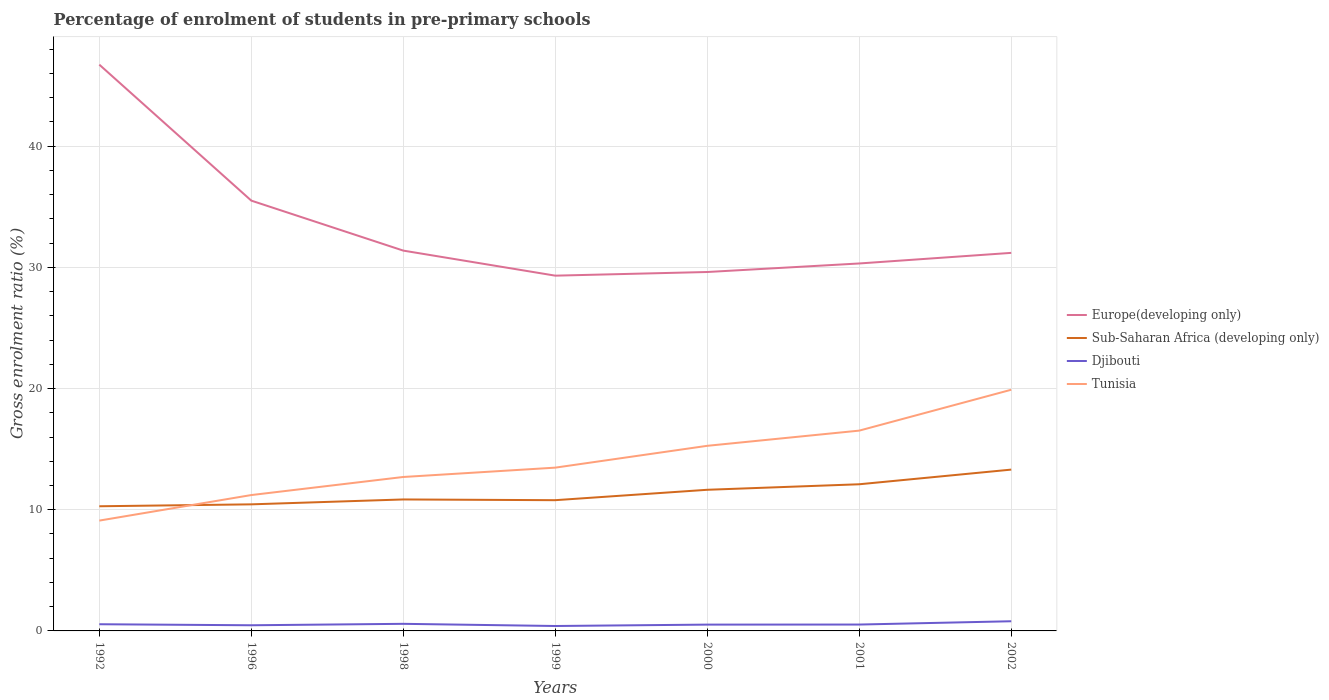Does the line corresponding to Tunisia intersect with the line corresponding to Europe(developing only)?
Your response must be concise. No. Across all years, what is the maximum percentage of students enrolled in pre-primary schools in Sub-Saharan Africa (developing only)?
Make the answer very short. 10.28. In which year was the percentage of students enrolled in pre-primary schools in Tunisia maximum?
Offer a terse response. 1992. What is the total percentage of students enrolled in pre-primary schools in Tunisia in the graph?
Your answer should be compact. -3.6. What is the difference between the highest and the second highest percentage of students enrolled in pre-primary schools in Sub-Saharan Africa (developing only)?
Ensure brevity in your answer.  3.03. How many lines are there?
Your response must be concise. 4. How many years are there in the graph?
Your answer should be very brief. 7. What is the difference between two consecutive major ticks on the Y-axis?
Your answer should be very brief. 10. Where does the legend appear in the graph?
Provide a short and direct response. Center right. What is the title of the graph?
Give a very brief answer. Percentage of enrolment of students in pre-primary schools. What is the label or title of the X-axis?
Offer a terse response. Years. What is the label or title of the Y-axis?
Make the answer very short. Gross enrolment ratio (%). What is the Gross enrolment ratio (%) of Europe(developing only) in 1992?
Ensure brevity in your answer.  46.72. What is the Gross enrolment ratio (%) in Sub-Saharan Africa (developing only) in 1992?
Provide a succinct answer. 10.28. What is the Gross enrolment ratio (%) in Djibouti in 1992?
Make the answer very short. 0.55. What is the Gross enrolment ratio (%) in Tunisia in 1992?
Your response must be concise. 9.1. What is the Gross enrolment ratio (%) in Europe(developing only) in 1996?
Your answer should be compact. 35.5. What is the Gross enrolment ratio (%) of Sub-Saharan Africa (developing only) in 1996?
Provide a succinct answer. 10.44. What is the Gross enrolment ratio (%) of Djibouti in 1996?
Your response must be concise. 0.47. What is the Gross enrolment ratio (%) of Tunisia in 1996?
Make the answer very short. 11.21. What is the Gross enrolment ratio (%) in Europe(developing only) in 1998?
Offer a terse response. 31.38. What is the Gross enrolment ratio (%) of Sub-Saharan Africa (developing only) in 1998?
Provide a succinct answer. 10.85. What is the Gross enrolment ratio (%) of Djibouti in 1998?
Your response must be concise. 0.58. What is the Gross enrolment ratio (%) of Tunisia in 1998?
Provide a short and direct response. 12.7. What is the Gross enrolment ratio (%) of Europe(developing only) in 1999?
Offer a terse response. 29.31. What is the Gross enrolment ratio (%) in Sub-Saharan Africa (developing only) in 1999?
Your answer should be compact. 10.79. What is the Gross enrolment ratio (%) in Djibouti in 1999?
Give a very brief answer. 0.41. What is the Gross enrolment ratio (%) in Tunisia in 1999?
Your response must be concise. 13.47. What is the Gross enrolment ratio (%) of Europe(developing only) in 2000?
Keep it short and to the point. 29.61. What is the Gross enrolment ratio (%) of Sub-Saharan Africa (developing only) in 2000?
Offer a very short reply. 11.65. What is the Gross enrolment ratio (%) of Djibouti in 2000?
Provide a short and direct response. 0.52. What is the Gross enrolment ratio (%) in Tunisia in 2000?
Offer a very short reply. 15.27. What is the Gross enrolment ratio (%) in Europe(developing only) in 2001?
Offer a very short reply. 30.32. What is the Gross enrolment ratio (%) of Sub-Saharan Africa (developing only) in 2001?
Provide a short and direct response. 12.1. What is the Gross enrolment ratio (%) in Djibouti in 2001?
Provide a succinct answer. 0.53. What is the Gross enrolment ratio (%) of Tunisia in 2001?
Ensure brevity in your answer.  16.53. What is the Gross enrolment ratio (%) in Europe(developing only) in 2002?
Make the answer very short. 31.19. What is the Gross enrolment ratio (%) in Sub-Saharan Africa (developing only) in 2002?
Offer a terse response. 13.31. What is the Gross enrolment ratio (%) in Djibouti in 2002?
Keep it short and to the point. 0.8. What is the Gross enrolment ratio (%) in Tunisia in 2002?
Make the answer very short. 19.9. Across all years, what is the maximum Gross enrolment ratio (%) in Europe(developing only)?
Your response must be concise. 46.72. Across all years, what is the maximum Gross enrolment ratio (%) of Sub-Saharan Africa (developing only)?
Keep it short and to the point. 13.31. Across all years, what is the maximum Gross enrolment ratio (%) of Djibouti?
Your answer should be compact. 0.8. Across all years, what is the maximum Gross enrolment ratio (%) in Tunisia?
Provide a succinct answer. 19.9. Across all years, what is the minimum Gross enrolment ratio (%) of Europe(developing only)?
Ensure brevity in your answer.  29.31. Across all years, what is the minimum Gross enrolment ratio (%) of Sub-Saharan Africa (developing only)?
Offer a very short reply. 10.28. Across all years, what is the minimum Gross enrolment ratio (%) in Djibouti?
Provide a short and direct response. 0.41. Across all years, what is the minimum Gross enrolment ratio (%) of Tunisia?
Your answer should be compact. 9.1. What is the total Gross enrolment ratio (%) in Europe(developing only) in the graph?
Provide a succinct answer. 234.04. What is the total Gross enrolment ratio (%) of Sub-Saharan Africa (developing only) in the graph?
Your answer should be very brief. 79.42. What is the total Gross enrolment ratio (%) in Djibouti in the graph?
Offer a very short reply. 3.85. What is the total Gross enrolment ratio (%) in Tunisia in the graph?
Make the answer very short. 98.19. What is the difference between the Gross enrolment ratio (%) of Europe(developing only) in 1992 and that in 1996?
Give a very brief answer. 11.22. What is the difference between the Gross enrolment ratio (%) of Sub-Saharan Africa (developing only) in 1992 and that in 1996?
Make the answer very short. -0.16. What is the difference between the Gross enrolment ratio (%) in Djibouti in 1992 and that in 1996?
Offer a very short reply. 0.09. What is the difference between the Gross enrolment ratio (%) in Tunisia in 1992 and that in 1996?
Make the answer very short. -2.11. What is the difference between the Gross enrolment ratio (%) of Europe(developing only) in 1992 and that in 1998?
Provide a succinct answer. 15.34. What is the difference between the Gross enrolment ratio (%) in Sub-Saharan Africa (developing only) in 1992 and that in 1998?
Make the answer very short. -0.56. What is the difference between the Gross enrolment ratio (%) of Djibouti in 1992 and that in 1998?
Your answer should be compact. -0.03. What is the difference between the Gross enrolment ratio (%) of Tunisia in 1992 and that in 1998?
Make the answer very short. -3.6. What is the difference between the Gross enrolment ratio (%) in Europe(developing only) in 1992 and that in 1999?
Offer a very short reply. 17.41. What is the difference between the Gross enrolment ratio (%) in Sub-Saharan Africa (developing only) in 1992 and that in 1999?
Offer a terse response. -0.5. What is the difference between the Gross enrolment ratio (%) of Djibouti in 1992 and that in 1999?
Make the answer very short. 0.15. What is the difference between the Gross enrolment ratio (%) in Tunisia in 1992 and that in 1999?
Give a very brief answer. -4.37. What is the difference between the Gross enrolment ratio (%) of Europe(developing only) in 1992 and that in 2000?
Make the answer very short. 17.11. What is the difference between the Gross enrolment ratio (%) in Sub-Saharan Africa (developing only) in 1992 and that in 2000?
Provide a short and direct response. -1.36. What is the difference between the Gross enrolment ratio (%) in Djibouti in 1992 and that in 2000?
Keep it short and to the point. 0.03. What is the difference between the Gross enrolment ratio (%) in Tunisia in 1992 and that in 2000?
Offer a very short reply. -6.17. What is the difference between the Gross enrolment ratio (%) of Europe(developing only) in 1992 and that in 2001?
Offer a terse response. 16.41. What is the difference between the Gross enrolment ratio (%) in Sub-Saharan Africa (developing only) in 1992 and that in 2001?
Offer a very short reply. -1.82. What is the difference between the Gross enrolment ratio (%) of Djibouti in 1992 and that in 2001?
Give a very brief answer. 0.03. What is the difference between the Gross enrolment ratio (%) in Tunisia in 1992 and that in 2001?
Your answer should be very brief. -7.42. What is the difference between the Gross enrolment ratio (%) in Europe(developing only) in 1992 and that in 2002?
Offer a very short reply. 15.53. What is the difference between the Gross enrolment ratio (%) in Sub-Saharan Africa (developing only) in 1992 and that in 2002?
Your response must be concise. -3.03. What is the difference between the Gross enrolment ratio (%) in Djibouti in 1992 and that in 2002?
Your response must be concise. -0.25. What is the difference between the Gross enrolment ratio (%) of Tunisia in 1992 and that in 2002?
Give a very brief answer. -10.8. What is the difference between the Gross enrolment ratio (%) in Europe(developing only) in 1996 and that in 1998?
Ensure brevity in your answer.  4.12. What is the difference between the Gross enrolment ratio (%) of Sub-Saharan Africa (developing only) in 1996 and that in 1998?
Make the answer very short. -0.4. What is the difference between the Gross enrolment ratio (%) in Djibouti in 1996 and that in 1998?
Offer a very short reply. -0.12. What is the difference between the Gross enrolment ratio (%) of Tunisia in 1996 and that in 1998?
Provide a short and direct response. -1.49. What is the difference between the Gross enrolment ratio (%) in Europe(developing only) in 1996 and that in 1999?
Offer a terse response. 6.19. What is the difference between the Gross enrolment ratio (%) in Sub-Saharan Africa (developing only) in 1996 and that in 1999?
Keep it short and to the point. -0.34. What is the difference between the Gross enrolment ratio (%) of Djibouti in 1996 and that in 1999?
Ensure brevity in your answer.  0.06. What is the difference between the Gross enrolment ratio (%) in Tunisia in 1996 and that in 1999?
Give a very brief answer. -2.26. What is the difference between the Gross enrolment ratio (%) of Europe(developing only) in 1996 and that in 2000?
Provide a succinct answer. 5.89. What is the difference between the Gross enrolment ratio (%) in Sub-Saharan Africa (developing only) in 1996 and that in 2000?
Your response must be concise. -1.2. What is the difference between the Gross enrolment ratio (%) of Djibouti in 1996 and that in 2000?
Make the answer very short. -0.05. What is the difference between the Gross enrolment ratio (%) of Tunisia in 1996 and that in 2000?
Keep it short and to the point. -4.06. What is the difference between the Gross enrolment ratio (%) of Europe(developing only) in 1996 and that in 2001?
Provide a succinct answer. 5.19. What is the difference between the Gross enrolment ratio (%) in Sub-Saharan Africa (developing only) in 1996 and that in 2001?
Provide a short and direct response. -1.66. What is the difference between the Gross enrolment ratio (%) of Djibouti in 1996 and that in 2001?
Your answer should be compact. -0.06. What is the difference between the Gross enrolment ratio (%) of Tunisia in 1996 and that in 2001?
Provide a short and direct response. -5.32. What is the difference between the Gross enrolment ratio (%) of Europe(developing only) in 1996 and that in 2002?
Provide a short and direct response. 4.31. What is the difference between the Gross enrolment ratio (%) in Sub-Saharan Africa (developing only) in 1996 and that in 2002?
Keep it short and to the point. -2.87. What is the difference between the Gross enrolment ratio (%) of Djibouti in 1996 and that in 2002?
Your response must be concise. -0.33. What is the difference between the Gross enrolment ratio (%) of Tunisia in 1996 and that in 2002?
Your answer should be compact. -8.69. What is the difference between the Gross enrolment ratio (%) in Europe(developing only) in 1998 and that in 1999?
Your answer should be compact. 2.07. What is the difference between the Gross enrolment ratio (%) of Sub-Saharan Africa (developing only) in 1998 and that in 1999?
Keep it short and to the point. 0.06. What is the difference between the Gross enrolment ratio (%) of Djibouti in 1998 and that in 1999?
Your response must be concise. 0.18. What is the difference between the Gross enrolment ratio (%) in Tunisia in 1998 and that in 1999?
Your answer should be very brief. -0.77. What is the difference between the Gross enrolment ratio (%) of Europe(developing only) in 1998 and that in 2000?
Give a very brief answer. 1.77. What is the difference between the Gross enrolment ratio (%) of Sub-Saharan Africa (developing only) in 1998 and that in 2000?
Your answer should be very brief. -0.8. What is the difference between the Gross enrolment ratio (%) of Djibouti in 1998 and that in 2000?
Make the answer very short. 0.06. What is the difference between the Gross enrolment ratio (%) in Tunisia in 1998 and that in 2000?
Provide a succinct answer. -2.57. What is the difference between the Gross enrolment ratio (%) of Europe(developing only) in 1998 and that in 2001?
Keep it short and to the point. 1.06. What is the difference between the Gross enrolment ratio (%) in Sub-Saharan Africa (developing only) in 1998 and that in 2001?
Your response must be concise. -1.25. What is the difference between the Gross enrolment ratio (%) in Djibouti in 1998 and that in 2001?
Your response must be concise. 0.06. What is the difference between the Gross enrolment ratio (%) of Tunisia in 1998 and that in 2001?
Give a very brief answer. -3.83. What is the difference between the Gross enrolment ratio (%) in Europe(developing only) in 1998 and that in 2002?
Your answer should be compact. 0.19. What is the difference between the Gross enrolment ratio (%) in Sub-Saharan Africa (developing only) in 1998 and that in 2002?
Give a very brief answer. -2.46. What is the difference between the Gross enrolment ratio (%) in Djibouti in 1998 and that in 2002?
Provide a succinct answer. -0.21. What is the difference between the Gross enrolment ratio (%) of Tunisia in 1998 and that in 2002?
Your answer should be compact. -7.2. What is the difference between the Gross enrolment ratio (%) of Europe(developing only) in 1999 and that in 2000?
Offer a terse response. -0.3. What is the difference between the Gross enrolment ratio (%) in Sub-Saharan Africa (developing only) in 1999 and that in 2000?
Your answer should be compact. -0.86. What is the difference between the Gross enrolment ratio (%) of Djibouti in 1999 and that in 2000?
Your answer should be very brief. -0.12. What is the difference between the Gross enrolment ratio (%) of Tunisia in 1999 and that in 2000?
Keep it short and to the point. -1.8. What is the difference between the Gross enrolment ratio (%) in Europe(developing only) in 1999 and that in 2001?
Provide a succinct answer. -1.01. What is the difference between the Gross enrolment ratio (%) in Sub-Saharan Africa (developing only) in 1999 and that in 2001?
Keep it short and to the point. -1.31. What is the difference between the Gross enrolment ratio (%) of Djibouti in 1999 and that in 2001?
Keep it short and to the point. -0.12. What is the difference between the Gross enrolment ratio (%) in Tunisia in 1999 and that in 2001?
Provide a short and direct response. -3.05. What is the difference between the Gross enrolment ratio (%) of Europe(developing only) in 1999 and that in 2002?
Your response must be concise. -1.88. What is the difference between the Gross enrolment ratio (%) of Sub-Saharan Africa (developing only) in 1999 and that in 2002?
Keep it short and to the point. -2.52. What is the difference between the Gross enrolment ratio (%) of Djibouti in 1999 and that in 2002?
Give a very brief answer. -0.39. What is the difference between the Gross enrolment ratio (%) in Tunisia in 1999 and that in 2002?
Give a very brief answer. -6.43. What is the difference between the Gross enrolment ratio (%) of Europe(developing only) in 2000 and that in 2001?
Offer a very short reply. -0.7. What is the difference between the Gross enrolment ratio (%) in Sub-Saharan Africa (developing only) in 2000 and that in 2001?
Your answer should be compact. -0.46. What is the difference between the Gross enrolment ratio (%) of Djibouti in 2000 and that in 2001?
Your answer should be very brief. -0.01. What is the difference between the Gross enrolment ratio (%) in Tunisia in 2000 and that in 2001?
Offer a terse response. -1.25. What is the difference between the Gross enrolment ratio (%) of Europe(developing only) in 2000 and that in 2002?
Your answer should be very brief. -1.58. What is the difference between the Gross enrolment ratio (%) in Sub-Saharan Africa (developing only) in 2000 and that in 2002?
Make the answer very short. -1.67. What is the difference between the Gross enrolment ratio (%) of Djibouti in 2000 and that in 2002?
Ensure brevity in your answer.  -0.28. What is the difference between the Gross enrolment ratio (%) in Tunisia in 2000 and that in 2002?
Your answer should be compact. -4.63. What is the difference between the Gross enrolment ratio (%) in Europe(developing only) in 2001 and that in 2002?
Make the answer very short. -0.88. What is the difference between the Gross enrolment ratio (%) in Sub-Saharan Africa (developing only) in 2001 and that in 2002?
Provide a succinct answer. -1.21. What is the difference between the Gross enrolment ratio (%) in Djibouti in 2001 and that in 2002?
Your answer should be compact. -0.27. What is the difference between the Gross enrolment ratio (%) of Tunisia in 2001 and that in 2002?
Give a very brief answer. -3.37. What is the difference between the Gross enrolment ratio (%) of Europe(developing only) in 1992 and the Gross enrolment ratio (%) of Sub-Saharan Africa (developing only) in 1996?
Your response must be concise. 36.28. What is the difference between the Gross enrolment ratio (%) in Europe(developing only) in 1992 and the Gross enrolment ratio (%) in Djibouti in 1996?
Give a very brief answer. 46.26. What is the difference between the Gross enrolment ratio (%) of Europe(developing only) in 1992 and the Gross enrolment ratio (%) of Tunisia in 1996?
Provide a succinct answer. 35.51. What is the difference between the Gross enrolment ratio (%) in Sub-Saharan Africa (developing only) in 1992 and the Gross enrolment ratio (%) in Djibouti in 1996?
Keep it short and to the point. 9.82. What is the difference between the Gross enrolment ratio (%) in Sub-Saharan Africa (developing only) in 1992 and the Gross enrolment ratio (%) in Tunisia in 1996?
Your response must be concise. -0.93. What is the difference between the Gross enrolment ratio (%) of Djibouti in 1992 and the Gross enrolment ratio (%) of Tunisia in 1996?
Offer a terse response. -10.66. What is the difference between the Gross enrolment ratio (%) in Europe(developing only) in 1992 and the Gross enrolment ratio (%) in Sub-Saharan Africa (developing only) in 1998?
Make the answer very short. 35.88. What is the difference between the Gross enrolment ratio (%) of Europe(developing only) in 1992 and the Gross enrolment ratio (%) of Djibouti in 1998?
Your response must be concise. 46.14. What is the difference between the Gross enrolment ratio (%) in Europe(developing only) in 1992 and the Gross enrolment ratio (%) in Tunisia in 1998?
Your response must be concise. 34.02. What is the difference between the Gross enrolment ratio (%) in Sub-Saharan Africa (developing only) in 1992 and the Gross enrolment ratio (%) in Djibouti in 1998?
Your answer should be compact. 9.7. What is the difference between the Gross enrolment ratio (%) in Sub-Saharan Africa (developing only) in 1992 and the Gross enrolment ratio (%) in Tunisia in 1998?
Provide a short and direct response. -2.42. What is the difference between the Gross enrolment ratio (%) of Djibouti in 1992 and the Gross enrolment ratio (%) of Tunisia in 1998?
Offer a very short reply. -12.15. What is the difference between the Gross enrolment ratio (%) in Europe(developing only) in 1992 and the Gross enrolment ratio (%) in Sub-Saharan Africa (developing only) in 1999?
Your answer should be very brief. 35.94. What is the difference between the Gross enrolment ratio (%) of Europe(developing only) in 1992 and the Gross enrolment ratio (%) of Djibouti in 1999?
Provide a short and direct response. 46.32. What is the difference between the Gross enrolment ratio (%) in Europe(developing only) in 1992 and the Gross enrolment ratio (%) in Tunisia in 1999?
Your answer should be very brief. 33.25. What is the difference between the Gross enrolment ratio (%) of Sub-Saharan Africa (developing only) in 1992 and the Gross enrolment ratio (%) of Djibouti in 1999?
Give a very brief answer. 9.88. What is the difference between the Gross enrolment ratio (%) in Sub-Saharan Africa (developing only) in 1992 and the Gross enrolment ratio (%) in Tunisia in 1999?
Make the answer very short. -3.19. What is the difference between the Gross enrolment ratio (%) in Djibouti in 1992 and the Gross enrolment ratio (%) in Tunisia in 1999?
Your response must be concise. -12.92. What is the difference between the Gross enrolment ratio (%) of Europe(developing only) in 1992 and the Gross enrolment ratio (%) of Sub-Saharan Africa (developing only) in 2000?
Make the answer very short. 35.08. What is the difference between the Gross enrolment ratio (%) of Europe(developing only) in 1992 and the Gross enrolment ratio (%) of Djibouti in 2000?
Provide a succinct answer. 46.2. What is the difference between the Gross enrolment ratio (%) in Europe(developing only) in 1992 and the Gross enrolment ratio (%) in Tunisia in 2000?
Make the answer very short. 31.45. What is the difference between the Gross enrolment ratio (%) of Sub-Saharan Africa (developing only) in 1992 and the Gross enrolment ratio (%) of Djibouti in 2000?
Your response must be concise. 9.76. What is the difference between the Gross enrolment ratio (%) in Sub-Saharan Africa (developing only) in 1992 and the Gross enrolment ratio (%) in Tunisia in 2000?
Your response must be concise. -4.99. What is the difference between the Gross enrolment ratio (%) in Djibouti in 1992 and the Gross enrolment ratio (%) in Tunisia in 2000?
Keep it short and to the point. -14.72. What is the difference between the Gross enrolment ratio (%) in Europe(developing only) in 1992 and the Gross enrolment ratio (%) in Sub-Saharan Africa (developing only) in 2001?
Your answer should be very brief. 34.62. What is the difference between the Gross enrolment ratio (%) of Europe(developing only) in 1992 and the Gross enrolment ratio (%) of Djibouti in 2001?
Your answer should be very brief. 46.2. What is the difference between the Gross enrolment ratio (%) in Europe(developing only) in 1992 and the Gross enrolment ratio (%) in Tunisia in 2001?
Your answer should be compact. 30.2. What is the difference between the Gross enrolment ratio (%) of Sub-Saharan Africa (developing only) in 1992 and the Gross enrolment ratio (%) of Djibouti in 2001?
Provide a short and direct response. 9.76. What is the difference between the Gross enrolment ratio (%) of Sub-Saharan Africa (developing only) in 1992 and the Gross enrolment ratio (%) of Tunisia in 2001?
Offer a terse response. -6.24. What is the difference between the Gross enrolment ratio (%) of Djibouti in 1992 and the Gross enrolment ratio (%) of Tunisia in 2001?
Give a very brief answer. -15.97. What is the difference between the Gross enrolment ratio (%) in Europe(developing only) in 1992 and the Gross enrolment ratio (%) in Sub-Saharan Africa (developing only) in 2002?
Your answer should be very brief. 33.41. What is the difference between the Gross enrolment ratio (%) in Europe(developing only) in 1992 and the Gross enrolment ratio (%) in Djibouti in 2002?
Keep it short and to the point. 45.93. What is the difference between the Gross enrolment ratio (%) of Europe(developing only) in 1992 and the Gross enrolment ratio (%) of Tunisia in 2002?
Keep it short and to the point. 26.82. What is the difference between the Gross enrolment ratio (%) of Sub-Saharan Africa (developing only) in 1992 and the Gross enrolment ratio (%) of Djibouti in 2002?
Offer a very short reply. 9.49. What is the difference between the Gross enrolment ratio (%) of Sub-Saharan Africa (developing only) in 1992 and the Gross enrolment ratio (%) of Tunisia in 2002?
Keep it short and to the point. -9.61. What is the difference between the Gross enrolment ratio (%) in Djibouti in 1992 and the Gross enrolment ratio (%) in Tunisia in 2002?
Ensure brevity in your answer.  -19.35. What is the difference between the Gross enrolment ratio (%) of Europe(developing only) in 1996 and the Gross enrolment ratio (%) of Sub-Saharan Africa (developing only) in 1998?
Keep it short and to the point. 24.66. What is the difference between the Gross enrolment ratio (%) of Europe(developing only) in 1996 and the Gross enrolment ratio (%) of Djibouti in 1998?
Your answer should be compact. 34.92. What is the difference between the Gross enrolment ratio (%) of Europe(developing only) in 1996 and the Gross enrolment ratio (%) of Tunisia in 1998?
Your answer should be compact. 22.8. What is the difference between the Gross enrolment ratio (%) in Sub-Saharan Africa (developing only) in 1996 and the Gross enrolment ratio (%) in Djibouti in 1998?
Provide a succinct answer. 9.86. What is the difference between the Gross enrolment ratio (%) of Sub-Saharan Africa (developing only) in 1996 and the Gross enrolment ratio (%) of Tunisia in 1998?
Provide a succinct answer. -2.26. What is the difference between the Gross enrolment ratio (%) in Djibouti in 1996 and the Gross enrolment ratio (%) in Tunisia in 1998?
Your answer should be compact. -12.23. What is the difference between the Gross enrolment ratio (%) in Europe(developing only) in 1996 and the Gross enrolment ratio (%) in Sub-Saharan Africa (developing only) in 1999?
Give a very brief answer. 24.72. What is the difference between the Gross enrolment ratio (%) of Europe(developing only) in 1996 and the Gross enrolment ratio (%) of Djibouti in 1999?
Offer a terse response. 35.1. What is the difference between the Gross enrolment ratio (%) of Europe(developing only) in 1996 and the Gross enrolment ratio (%) of Tunisia in 1999?
Keep it short and to the point. 22.03. What is the difference between the Gross enrolment ratio (%) of Sub-Saharan Africa (developing only) in 1996 and the Gross enrolment ratio (%) of Djibouti in 1999?
Offer a terse response. 10.04. What is the difference between the Gross enrolment ratio (%) in Sub-Saharan Africa (developing only) in 1996 and the Gross enrolment ratio (%) in Tunisia in 1999?
Ensure brevity in your answer.  -3.03. What is the difference between the Gross enrolment ratio (%) of Djibouti in 1996 and the Gross enrolment ratio (%) of Tunisia in 1999?
Your answer should be compact. -13.01. What is the difference between the Gross enrolment ratio (%) of Europe(developing only) in 1996 and the Gross enrolment ratio (%) of Sub-Saharan Africa (developing only) in 2000?
Your answer should be very brief. 23.86. What is the difference between the Gross enrolment ratio (%) in Europe(developing only) in 1996 and the Gross enrolment ratio (%) in Djibouti in 2000?
Offer a very short reply. 34.98. What is the difference between the Gross enrolment ratio (%) in Europe(developing only) in 1996 and the Gross enrolment ratio (%) in Tunisia in 2000?
Your answer should be compact. 20.23. What is the difference between the Gross enrolment ratio (%) of Sub-Saharan Africa (developing only) in 1996 and the Gross enrolment ratio (%) of Djibouti in 2000?
Keep it short and to the point. 9.92. What is the difference between the Gross enrolment ratio (%) of Sub-Saharan Africa (developing only) in 1996 and the Gross enrolment ratio (%) of Tunisia in 2000?
Your response must be concise. -4.83. What is the difference between the Gross enrolment ratio (%) in Djibouti in 1996 and the Gross enrolment ratio (%) in Tunisia in 2000?
Provide a succinct answer. -14.81. What is the difference between the Gross enrolment ratio (%) in Europe(developing only) in 1996 and the Gross enrolment ratio (%) in Sub-Saharan Africa (developing only) in 2001?
Provide a short and direct response. 23.4. What is the difference between the Gross enrolment ratio (%) in Europe(developing only) in 1996 and the Gross enrolment ratio (%) in Djibouti in 2001?
Make the answer very short. 34.98. What is the difference between the Gross enrolment ratio (%) of Europe(developing only) in 1996 and the Gross enrolment ratio (%) of Tunisia in 2001?
Your response must be concise. 18.98. What is the difference between the Gross enrolment ratio (%) of Sub-Saharan Africa (developing only) in 1996 and the Gross enrolment ratio (%) of Djibouti in 2001?
Give a very brief answer. 9.92. What is the difference between the Gross enrolment ratio (%) in Sub-Saharan Africa (developing only) in 1996 and the Gross enrolment ratio (%) in Tunisia in 2001?
Keep it short and to the point. -6.08. What is the difference between the Gross enrolment ratio (%) of Djibouti in 1996 and the Gross enrolment ratio (%) of Tunisia in 2001?
Your answer should be very brief. -16.06. What is the difference between the Gross enrolment ratio (%) in Europe(developing only) in 1996 and the Gross enrolment ratio (%) in Sub-Saharan Africa (developing only) in 2002?
Ensure brevity in your answer.  22.19. What is the difference between the Gross enrolment ratio (%) in Europe(developing only) in 1996 and the Gross enrolment ratio (%) in Djibouti in 2002?
Your response must be concise. 34.71. What is the difference between the Gross enrolment ratio (%) in Europe(developing only) in 1996 and the Gross enrolment ratio (%) in Tunisia in 2002?
Give a very brief answer. 15.6. What is the difference between the Gross enrolment ratio (%) of Sub-Saharan Africa (developing only) in 1996 and the Gross enrolment ratio (%) of Djibouti in 2002?
Ensure brevity in your answer.  9.65. What is the difference between the Gross enrolment ratio (%) of Sub-Saharan Africa (developing only) in 1996 and the Gross enrolment ratio (%) of Tunisia in 2002?
Give a very brief answer. -9.46. What is the difference between the Gross enrolment ratio (%) of Djibouti in 1996 and the Gross enrolment ratio (%) of Tunisia in 2002?
Offer a very short reply. -19.43. What is the difference between the Gross enrolment ratio (%) in Europe(developing only) in 1998 and the Gross enrolment ratio (%) in Sub-Saharan Africa (developing only) in 1999?
Your answer should be compact. 20.59. What is the difference between the Gross enrolment ratio (%) in Europe(developing only) in 1998 and the Gross enrolment ratio (%) in Djibouti in 1999?
Give a very brief answer. 30.97. What is the difference between the Gross enrolment ratio (%) of Europe(developing only) in 1998 and the Gross enrolment ratio (%) of Tunisia in 1999?
Give a very brief answer. 17.91. What is the difference between the Gross enrolment ratio (%) of Sub-Saharan Africa (developing only) in 1998 and the Gross enrolment ratio (%) of Djibouti in 1999?
Provide a short and direct response. 10.44. What is the difference between the Gross enrolment ratio (%) of Sub-Saharan Africa (developing only) in 1998 and the Gross enrolment ratio (%) of Tunisia in 1999?
Ensure brevity in your answer.  -2.63. What is the difference between the Gross enrolment ratio (%) in Djibouti in 1998 and the Gross enrolment ratio (%) in Tunisia in 1999?
Make the answer very short. -12.89. What is the difference between the Gross enrolment ratio (%) of Europe(developing only) in 1998 and the Gross enrolment ratio (%) of Sub-Saharan Africa (developing only) in 2000?
Your response must be concise. 19.73. What is the difference between the Gross enrolment ratio (%) in Europe(developing only) in 1998 and the Gross enrolment ratio (%) in Djibouti in 2000?
Provide a short and direct response. 30.86. What is the difference between the Gross enrolment ratio (%) in Europe(developing only) in 1998 and the Gross enrolment ratio (%) in Tunisia in 2000?
Your response must be concise. 16.11. What is the difference between the Gross enrolment ratio (%) in Sub-Saharan Africa (developing only) in 1998 and the Gross enrolment ratio (%) in Djibouti in 2000?
Ensure brevity in your answer.  10.33. What is the difference between the Gross enrolment ratio (%) of Sub-Saharan Africa (developing only) in 1998 and the Gross enrolment ratio (%) of Tunisia in 2000?
Your response must be concise. -4.43. What is the difference between the Gross enrolment ratio (%) of Djibouti in 1998 and the Gross enrolment ratio (%) of Tunisia in 2000?
Make the answer very short. -14.69. What is the difference between the Gross enrolment ratio (%) in Europe(developing only) in 1998 and the Gross enrolment ratio (%) in Sub-Saharan Africa (developing only) in 2001?
Offer a terse response. 19.28. What is the difference between the Gross enrolment ratio (%) in Europe(developing only) in 1998 and the Gross enrolment ratio (%) in Djibouti in 2001?
Make the answer very short. 30.85. What is the difference between the Gross enrolment ratio (%) of Europe(developing only) in 1998 and the Gross enrolment ratio (%) of Tunisia in 2001?
Keep it short and to the point. 14.85. What is the difference between the Gross enrolment ratio (%) in Sub-Saharan Africa (developing only) in 1998 and the Gross enrolment ratio (%) in Djibouti in 2001?
Offer a very short reply. 10.32. What is the difference between the Gross enrolment ratio (%) of Sub-Saharan Africa (developing only) in 1998 and the Gross enrolment ratio (%) of Tunisia in 2001?
Ensure brevity in your answer.  -5.68. What is the difference between the Gross enrolment ratio (%) in Djibouti in 1998 and the Gross enrolment ratio (%) in Tunisia in 2001?
Make the answer very short. -15.94. What is the difference between the Gross enrolment ratio (%) of Europe(developing only) in 1998 and the Gross enrolment ratio (%) of Sub-Saharan Africa (developing only) in 2002?
Your answer should be compact. 18.07. What is the difference between the Gross enrolment ratio (%) in Europe(developing only) in 1998 and the Gross enrolment ratio (%) in Djibouti in 2002?
Give a very brief answer. 30.58. What is the difference between the Gross enrolment ratio (%) of Europe(developing only) in 1998 and the Gross enrolment ratio (%) of Tunisia in 2002?
Your answer should be compact. 11.48. What is the difference between the Gross enrolment ratio (%) of Sub-Saharan Africa (developing only) in 1998 and the Gross enrolment ratio (%) of Djibouti in 2002?
Your answer should be compact. 10.05. What is the difference between the Gross enrolment ratio (%) of Sub-Saharan Africa (developing only) in 1998 and the Gross enrolment ratio (%) of Tunisia in 2002?
Provide a succinct answer. -9.05. What is the difference between the Gross enrolment ratio (%) of Djibouti in 1998 and the Gross enrolment ratio (%) of Tunisia in 2002?
Ensure brevity in your answer.  -19.31. What is the difference between the Gross enrolment ratio (%) of Europe(developing only) in 1999 and the Gross enrolment ratio (%) of Sub-Saharan Africa (developing only) in 2000?
Provide a succinct answer. 17.67. What is the difference between the Gross enrolment ratio (%) of Europe(developing only) in 1999 and the Gross enrolment ratio (%) of Djibouti in 2000?
Make the answer very short. 28.79. What is the difference between the Gross enrolment ratio (%) of Europe(developing only) in 1999 and the Gross enrolment ratio (%) of Tunisia in 2000?
Keep it short and to the point. 14.04. What is the difference between the Gross enrolment ratio (%) in Sub-Saharan Africa (developing only) in 1999 and the Gross enrolment ratio (%) in Djibouti in 2000?
Your response must be concise. 10.27. What is the difference between the Gross enrolment ratio (%) in Sub-Saharan Africa (developing only) in 1999 and the Gross enrolment ratio (%) in Tunisia in 2000?
Your answer should be compact. -4.49. What is the difference between the Gross enrolment ratio (%) in Djibouti in 1999 and the Gross enrolment ratio (%) in Tunisia in 2000?
Offer a terse response. -14.87. What is the difference between the Gross enrolment ratio (%) in Europe(developing only) in 1999 and the Gross enrolment ratio (%) in Sub-Saharan Africa (developing only) in 2001?
Provide a short and direct response. 17.21. What is the difference between the Gross enrolment ratio (%) of Europe(developing only) in 1999 and the Gross enrolment ratio (%) of Djibouti in 2001?
Your answer should be compact. 28.79. What is the difference between the Gross enrolment ratio (%) in Europe(developing only) in 1999 and the Gross enrolment ratio (%) in Tunisia in 2001?
Your answer should be compact. 12.79. What is the difference between the Gross enrolment ratio (%) in Sub-Saharan Africa (developing only) in 1999 and the Gross enrolment ratio (%) in Djibouti in 2001?
Offer a terse response. 10.26. What is the difference between the Gross enrolment ratio (%) in Sub-Saharan Africa (developing only) in 1999 and the Gross enrolment ratio (%) in Tunisia in 2001?
Provide a succinct answer. -5.74. What is the difference between the Gross enrolment ratio (%) in Djibouti in 1999 and the Gross enrolment ratio (%) in Tunisia in 2001?
Your answer should be compact. -16.12. What is the difference between the Gross enrolment ratio (%) in Europe(developing only) in 1999 and the Gross enrolment ratio (%) in Sub-Saharan Africa (developing only) in 2002?
Provide a short and direct response. 16. What is the difference between the Gross enrolment ratio (%) in Europe(developing only) in 1999 and the Gross enrolment ratio (%) in Djibouti in 2002?
Your answer should be very brief. 28.51. What is the difference between the Gross enrolment ratio (%) in Europe(developing only) in 1999 and the Gross enrolment ratio (%) in Tunisia in 2002?
Your answer should be compact. 9.41. What is the difference between the Gross enrolment ratio (%) of Sub-Saharan Africa (developing only) in 1999 and the Gross enrolment ratio (%) of Djibouti in 2002?
Keep it short and to the point. 9.99. What is the difference between the Gross enrolment ratio (%) of Sub-Saharan Africa (developing only) in 1999 and the Gross enrolment ratio (%) of Tunisia in 2002?
Keep it short and to the point. -9.11. What is the difference between the Gross enrolment ratio (%) of Djibouti in 1999 and the Gross enrolment ratio (%) of Tunisia in 2002?
Your answer should be compact. -19.49. What is the difference between the Gross enrolment ratio (%) in Europe(developing only) in 2000 and the Gross enrolment ratio (%) in Sub-Saharan Africa (developing only) in 2001?
Your answer should be compact. 17.51. What is the difference between the Gross enrolment ratio (%) of Europe(developing only) in 2000 and the Gross enrolment ratio (%) of Djibouti in 2001?
Provide a succinct answer. 29.09. What is the difference between the Gross enrolment ratio (%) in Europe(developing only) in 2000 and the Gross enrolment ratio (%) in Tunisia in 2001?
Your answer should be very brief. 13.09. What is the difference between the Gross enrolment ratio (%) in Sub-Saharan Africa (developing only) in 2000 and the Gross enrolment ratio (%) in Djibouti in 2001?
Give a very brief answer. 11.12. What is the difference between the Gross enrolment ratio (%) in Sub-Saharan Africa (developing only) in 2000 and the Gross enrolment ratio (%) in Tunisia in 2001?
Provide a succinct answer. -4.88. What is the difference between the Gross enrolment ratio (%) of Djibouti in 2000 and the Gross enrolment ratio (%) of Tunisia in 2001?
Ensure brevity in your answer.  -16.01. What is the difference between the Gross enrolment ratio (%) of Europe(developing only) in 2000 and the Gross enrolment ratio (%) of Sub-Saharan Africa (developing only) in 2002?
Your response must be concise. 16.3. What is the difference between the Gross enrolment ratio (%) of Europe(developing only) in 2000 and the Gross enrolment ratio (%) of Djibouti in 2002?
Your answer should be very brief. 28.82. What is the difference between the Gross enrolment ratio (%) in Europe(developing only) in 2000 and the Gross enrolment ratio (%) in Tunisia in 2002?
Offer a very short reply. 9.71. What is the difference between the Gross enrolment ratio (%) of Sub-Saharan Africa (developing only) in 2000 and the Gross enrolment ratio (%) of Djibouti in 2002?
Provide a succinct answer. 10.85. What is the difference between the Gross enrolment ratio (%) in Sub-Saharan Africa (developing only) in 2000 and the Gross enrolment ratio (%) in Tunisia in 2002?
Offer a very short reply. -8.25. What is the difference between the Gross enrolment ratio (%) in Djibouti in 2000 and the Gross enrolment ratio (%) in Tunisia in 2002?
Your response must be concise. -19.38. What is the difference between the Gross enrolment ratio (%) of Europe(developing only) in 2001 and the Gross enrolment ratio (%) of Sub-Saharan Africa (developing only) in 2002?
Keep it short and to the point. 17.01. What is the difference between the Gross enrolment ratio (%) in Europe(developing only) in 2001 and the Gross enrolment ratio (%) in Djibouti in 2002?
Make the answer very short. 29.52. What is the difference between the Gross enrolment ratio (%) in Europe(developing only) in 2001 and the Gross enrolment ratio (%) in Tunisia in 2002?
Provide a short and direct response. 10.42. What is the difference between the Gross enrolment ratio (%) in Sub-Saharan Africa (developing only) in 2001 and the Gross enrolment ratio (%) in Djibouti in 2002?
Offer a very short reply. 11.3. What is the difference between the Gross enrolment ratio (%) in Sub-Saharan Africa (developing only) in 2001 and the Gross enrolment ratio (%) in Tunisia in 2002?
Your response must be concise. -7.8. What is the difference between the Gross enrolment ratio (%) in Djibouti in 2001 and the Gross enrolment ratio (%) in Tunisia in 2002?
Your answer should be very brief. -19.37. What is the average Gross enrolment ratio (%) in Europe(developing only) per year?
Offer a very short reply. 33.43. What is the average Gross enrolment ratio (%) of Sub-Saharan Africa (developing only) per year?
Your answer should be very brief. 11.35. What is the average Gross enrolment ratio (%) of Djibouti per year?
Offer a terse response. 0.55. What is the average Gross enrolment ratio (%) of Tunisia per year?
Keep it short and to the point. 14.03. In the year 1992, what is the difference between the Gross enrolment ratio (%) in Europe(developing only) and Gross enrolment ratio (%) in Sub-Saharan Africa (developing only)?
Ensure brevity in your answer.  36.44. In the year 1992, what is the difference between the Gross enrolment ratio (%) of Europe(developing only) and Gross enrolment ratio (%) of Djibouti?
Provide a succinct answer. 46.17. In the year 1992, what is the difference between the Gross enrolment ratio (%) of Europe(developing only) and Gross enrolment ratio (%) of Tunisia?
Keep it short and to the point. 37.62. In the year 1992, what is the difference between the Gross enrolment ratio (%) in Sub-Saharan Africa (developing only) and Gross enrolment ratio (%) in Djibouti?
Give a very brief answer. 9.73. In the year 1992, what is the difference between the Gross enrolment ratio (%) in Sub-Saharan Africa (developing only) and Gross enrolment ratio (%) in Tunisia?
Make the answer very short. 1.18. In the year 1992, what is the difference between the Gross enrolment ratio (%) of Djibouti and Gross enrolment ratio (%) of Tunisia?
Provide a short and direct response. -8.55. In the year 1996, what is the difference between the Gross enrolment ratio (%) in Europe(developing only) and Gross enrolment ratio (%) in Sub-Saharan Africa (developing only)?
Your answer should be very brief. 25.06. In the year 1996, what is the difference between the Gross enrolment ratio (%) in Europe(developing only) and Gross enrolment ratio (%) in Djibouti?
Provide a succinct answer. 35.04. In the year 1996, what is the difference between the Gross enrolment ratio (%) of Europe(developing only) and Gross enrolment ratio (%) of Tunisia?
Give a very brief answer. 24.29. In the year 1996, what is the difference between the Gross enrolment ratio (%) in Sub-Saharan Africa (developing only) and Gross enrolment ratio (%) in Djibouti?
Your response must be concise. 9.98. In the year 1996, what is the difference between the Gross enrolment ratio (%) in Sub-Saharan Africa (developing only) and Gross enrolment ratio (%) in Tunisia?
Your answer should be very brief. -0.77. In the year 1996, what is the difference between the Gross enrolment ratio (%) in Djibouti and Gross enrolment ratio (%) in Tunisia?
Your answer should be very brief. -10.74. In the year 1998, what is the difference between the Gross enrolment ratio (%) in Europe(developing only) and Gross enrolment ratio (%) in Sub-Saharan Africa (developing only)?
Provide a short and direct response. 20.53. In the year 1998, what is the difference between the Gross enrolment ratio (%) in Europe(developing only) and Gross enrolment ratio (%) in Djibouti?
Give a very brief answer. 30.79. In the year 1998, what is the difference between the Gross enrolment ratio (%) in Europe(developing only) and Gross enrolment ratio (%) in Tunisia?
Your response must be concise. 18.68. In the year 1998, what is the difference between the Gross enrolment ratio (%) in Sub-Saharan Africa (developing only) and Gross enrolment ratio (%) in Djibouti?
Provide a succinct answer. 10.26. In the year 1998, what is the difference between the Gross enrolment ratio (%) of Sub-Saharan Africa (developing only) and Gross enrolment ratio (%) of Tunisia?
Your response must be concise. -1.85. In the year 1998, what is the difference between the Gross enrolment ratio (%) in Djibouti and Gross enrolment ratio (%) in Tunisia?
Ensure brevity in your answer.  -12.12. In the year 1999, what is the difference between the Gross enrolment ratio (%) of Europe(developing only) and Gross enrolment ratio (%) of Sub-Saharan Africa (developing only)?
Provide a short and direct response. 18.52. In the year 1999, what is the difference between the Gross enrolment ratio (%) of Europe(developing only) and Gross enrolment ratio (%) of Djibouti?
Your answer should be very brief. 28.91. In the year 1999, what is the difference between the Gross enrolment ratio (%) in Europe(developing only) and Gross enrolment ratio (%) in Tunisia?
Provide a short and direct response. 15.84. In the year 1999, what is the difference between the Gross enrolment ratio (%) in Sub-Saharan Africa (developing only) and Gross enrolment ratio (%) in Djibouti?
Your answer should be very brief. 10.38. In the year 1999, what is the difference between the Gross enrolment ratio (%) in Sub-Saharan Africa (developing only) and Gross enrolment ratio (%) in Tunisia?
Your answer should be very brief. -2.68. In the year 1999, what is the difference between the Gross enrolment ratio (%) in Djibouti and Gross enrolment ratio (%) in Tunisia?
Your answer should be very brief. -13.07. In the year 2000, what is the difference between the Gross enrolment ratio (%) in Europe(developing only) and Gross enrolment ratio (%) in Sub-Saharan Africa (developing only)?
Provide a succinct answer. 17.97. In the year 2000, what is the difference between the Gross enrolment ratio (%) in Europe(developing only) and Gross enrolment ratio (%) in Djibouti?
Make the answer very short. 29.09. In the year 2000, what is the difference between the Gross enrolment ratio (%) of Europe(developing only) and Gross enrolment ratio (%) of Tunisia?
Your response must be concise. 14.34. In the year 2000, what is the difference between the Gross enrolment ratio (%) of Sub-Saharan Africa (developing only) and Gross enrolment ratio (%) of Djibouti?
Provide a short and direct response. 11.12. In the year 2000, what is the difference between the Gross enrolment ratio (%) of Sub-Saharan Africa (developing only) and Gross enrolment ratio (%) of Tunisia?
Your answer should be very brief. -3.63. In the year 2000, what is the difference between the Gross enrolment ratio (%) in Djibouti and Gross enrolment ratio (%) in Tunisia?
Your response must be concise. -14.75. In the year 2001, what is the difference between the Gross enrolment ratio (%) of Europe(developing only) and Gross enrolment ratio (%) of Sub-Saharan Africa (developing only)?
Your answer should be very brief. 18.22. In the year 2001, what is the difference between the Gross enrolment ratio (%) in Europe(developing only) and Gross enrolment ratio (%) in Djibouti?
Your answer should be very brief. 29.79. In the year 2001, what is the difference between the Gross enrolment ratio (%) of Europe(developing only) and Gross enrolment ratio (%) of Tunisia?
Your response must be concise. 13.79. In the year 2001, what is the difference between the Gross enrolment ratio (%) of Sub-Saharan Africa (developing only) and Gross enrolment ratio (%) of Djibouti?
Your answer should be compact. 11.57. In the year 2001, what is the difference between the Gross enrolment ratio (%) in Sub-Saharan Africa (developing only) and Gross enrolment ratio (%) in Tunisia?
Keep it short and to the point. -4.43. In the year 2001, what is the difference between the Gross enrolment ratio (%) of Djibouti and Gross enrolment ratio (%) of Tunisia?
Make the answer very short. -16. In the year 2002, what is the difference between the Gross enrolment ratio (%) of Europe(developing only) and Gross enrolment ratio (%) of Sub-Saharan Africa (developing only)?
Keep it short and to the point. 17.88. In the year 2002, what is the difference between the Gross enrolment ratio (%) of Europe(developing only) and Gross enrolment ratio (%) of Djibouti?
Your response must be concise. 30.4. In the year 2002, what is the difference between the Gross enrolment ratio (%) in Europe(developing only) and Gross enrolment ratio (%) in Tunisia?
Ensure brevity in your answer.  11.29. In the year 2002, what is the difference between the Gross enrolment ratio (%) of Sub-Saharan Africa (developing only) and Gross enrolment ratio (%) of Djibouti?
Your response must be concise. 12.51. In the year 2002, what is the difference between the Gross enrolment ratio (%) in Sub-Saharan Africa (developing only) and Gross enrolment ratio (%) in Tunisia?
Provide a succinct answer. -6.59. In the year 2002, what is the difference between the Gross enrolment ratio (%) of Djibouti and Gross enrolment ratio (%) of Tunisia?
Provide a succinct answer. -19.1. What is the ratio of the Gross enrolment ratio (%) of Europe(developing only) in 1992 to that in 1996?
Offer a very short reply. 1.32. What is the ratio of the Gross enrolment ratio (%) of Sub-Saharan Africa (developing only) in 1992 to that in 1996?
Your answer should be compact. 0.98. What is the ratio of the Gross enrolment ratio (%) in Djibouti in 1992 to that in 1996?
Provide a short and direct response. 1.18. What is the ratio of the Gross enrolment ratio (%) of Tunisia in 1992 to that in 1996?
Offer a terse response. 0.81. What is the ratio of the Gross enrolment ratio (%) of Europe(developing only) in 1992 to that in 1998?
Keep it short and to the point. 1.49. What is the ratio of the Gross enrolment ratio (%) of Sub-Saharan Africa (developing only) in 1992 to that in 1998?
Give a very brief answer. 0.95. What is the ratio of the Gross enrolment ratio (%) in Djibouti in 1992 to that in 1998?
Offer a terse response. 0.94. What is the ratio of the Gross enrolment ratio (%) in Tunisia in 1992 to that in 1998?
Provide a succinct answer. 0.72. What is the ratio of the Gross enrolment ratio (%) in Europe(developing only) in 1992 to that in 1999?
Your answer should be compact. 1.59. What is the ratio of the Gross enrolment ratio (%) of Sub-Saharan Africa (developing only) in 1992 to that in 1999?
Offer a terse response. 0.95. What is the ratio of the Gross enrolment ratio (%) in Djibouti in 1992 to that in 1999?
Your response must be concise. 1.36. What is the ratio of the Gross enrolment ratio (%) of Tunisia in 1992 to that in 1999?
Offer a very short reply. 0.68. What is the ratio of the Gross enrolment ratio (%) of Europe(developing only) in 1992 to that in 2000?
Offer a terse response. 1.58. What is the ratio of the Gross enrolment ratio (%) in Sub-Saharan Africa (developing only) in 1992 to that in 2000?
Give a very brief answer. 0.88. What is the ratio of the Gross enrolment ratio (%) of Djibouti in 1992 to that in 2000?
Offer a terse response. 1.06. What is the ratio of the Gross enrolment ratio (%) in Tunisia in 1992 to that in 2000?
Offer a terse response. 0.6. What is the ratio of the Gross enrolment ratio (%) of Europe(developing only) in 1992 to that in 2001?
Your answer should be very brief. 1.54. What is the ratio of the Gross enrolment ratio (%) of Djibouti in 1992 to that in 2001?
Keep it short and to the point. 1.05. What is the ratio of the Gross enrolment ratio (%) of Tunisia in 1992 to that in 2001?
Provide a succinct answer. 0.55. What is the ratio of the Gross enrolment ratio (%) of Europe(developing only) in 1992 to that in 2002?
Your response must be concise. 1.5. What is the ratio of the Gross enrolment ratio (%) in Sub-Saharan Africa (developing only) in 1992 to that in 2002?
Your answer should be compact. 0.77. What is the ratio of the Gross enrolment ratio (%) in Djibouti in 1992 to that in 2002?
Provide a succinct answer. 0.69. What is the ratio of the Gross enrolment ratio (%) of Tunisia in 1992 to that in 2002?
Provide a short and direct response. 0.46. What is the ratio of the Gross enrolment ratio (%) of Europe(developing only) in 1996 to that in 1998?
Provide a short and direct response. 1.13. What is the ratio of the Gross enrolment ratio (%) in Sub-Saharan Africa (developing only) in 1996 to that in 1998?
Keep it short and to the point. 0.96. What is the ratio of the Gross enrolment ratio (%) of Djibouti in 1996 to that in 1998?
Ensure brevity in your answer.  0.8. What is the ratio of the Gross enrolment ratio (%) in Tunisia in 1996 to that in 1998?
Offer a very short reply. 0.88. What is the ratio of the Gross enrolment ratio (%) of Europe(developing only) in 1996 to that in 1999?
Keep it short and to the point. 1.21. What is the ratio of the Gross enrolment ratio (%) of Sub-Saharan Africa (developing only) in 1996 to that in 1999?
Make the answer very short. 0.97. What is the ratio of the Gross enrolment ratio (%) in Djibouti in 1996 to that in 1999?
Offer a terse response. 1.15. What is the ratio of the Gross enrolment ratio (%) of Tunisia in 1996 to that in 1999?
Your response must be concise. 0.83. What is the ratio of the Gross enrolment ratio (%) in Europe(developing only) in 1996 to that in 2000?
Offer a very short reply. 1.2. What is the ratio of the Gross enrolment ratio (%) of Sub-Saharan Africa (developing only) in 1996 to that in 2000?
Give a very brief answer. 0.9. What is the ratio of the Gross enrolment ratio (%) of Djibouti in 1996 to that in 2000?
Keep it short and to the point. 0.9. What is the ratio of the Gross enrolment ratio (%) in Tunisia in 1996 to that in 2000?
Your response must be concise. 0.73. What is the ratio of the Gross enrolment ratio (%) of Europe(developing only) in 1996 to that in 2001?
Your response must be concise. 1.17. What is the ratio of the Gross enrolment ratio (%) of Sub-Saharan Africa (developing only) in 1996 to that in 2001?
Give a very brief answer. 0.86. What is the ratio of the Gross enrolment ratio (%) of Djibouti in 1996 to that in 2001?
Give a very brief answer. 0.89. What is the ratio of the Gross enrolment ratio (%) in Tunisia in 1996 to that in 2001?
Provide a succinct answer. 0.68. What is the ratio of the Gross enrolment ratio (%) in Europe(developing only) in 1996 to that in 2002?
Your answer should be compact. 1.14. What is the ratio of the Gross enrolment ratio (%) of Sub-Saharan Africa (developing only) in 1996 to that in 2002?
Offer a very short reply. 0.78. What is the ratio of the Gross enrolment ratio (%) in Djibouti in 1996 to that in 2002?
Your answer should be compact. 0.58. What is the ratio of the Gross enrolment ratio (%) of Tunisia in 1996 to that in 2002?
Ensure brevity in your answer.  0.56. What is the ratio of the Gross enrolment ratio (%) in Europe(developing only) in 1998 to that in 1999?
Offer a terse response. 1.07. What is the ratio of the Gross enrolment ratio (%) of Djibouti in 1998 to that in 1999?
Make the answer very short. 1.44. What is the ratio of the Gross enrolment ratio (%) of Tunisia in 1998 to that in 1999?
Provide a short and direct response. 0.94. What is the ratio of the Gross enrolment ratio (%) of Europe(developing only) in 1998 to that in 2000?
Provide a short and direct response. 1.06. What is the ratio of the Gross enrolment ratio (%) of Sub-Saharan Africa (developing only) in 1998 to that in 2000?
Ensure brevity in your answer.  0.93. What is the ratio of the Gross enrolment ratio (%) in Djibouti in 1998 to that in 2000?
Keep it short and to the point. 1.12. What is the ratio of the Gross enrolment ratio (%) in Tunisia in 1998 to that in 2000?
Your response must be concise. 0.83. What is the ratio of the Gross enrolment ratio (%) in Europe(developing only) in 1998 to that in 2001?
Provide a short and direct response. 1.03. What is the ratio of the Gross enrolment ratio (%) in Sub-Saharan Africa (developing only) in 1998 to that in 2001?
Offer a terse response. 0.9. What is the ratio of the Gross enrolment ratio (%) in Djibouti in 1998 to that in 2001?
Keep it short and to the point. 1.11. What is the ratio of the Gross enrolment ratio (%) in Tunisia in 1998 to that in 2001?
Your answer should be compact. 0.77. What is the ratio of the Gross enrolment ratio (%) in Europe(developing only) in 1998 to that in 2002?
Your answer should be very brief. 1.01. What is the ratio of the Gross enrolment ratio (%) of Sub-Saharan Africa (developing only) in 1998 to that in 2002?
Ensure brevity in your answer.  0.81. What is the ratio of the Gross enrolment ratio (%) of Djibouti in 1998 to that in 2002?
Ensure brevity in your answer.  0.73. What is the ratio of the Gross enrolment ratio (%) of Tunisia in 1998 to that in 2002?
Make the answer very short. 0.64. What is the ratio of the Gross enrolment ratio (%) in Sub-Saharan Africa (developing only) in 1999 to that in 2000?
Your answer should be compact. 0.93. What is the ratio of the Gross enrolment ratio (%) in Djibouti in 1999 to that in 2000?
Make the answer very short. 0.78. What is the ratio of the Gross enrolment ratio (%) in Tunisia in 1999 to that in 2000?
Ensure brevity in your answer.  0.88. What is the ratio of the Gross enrolment ratio (%) of Europe(developing only) in 1999 to that in 2001?
Keep it short and to the point. 0.97. What is the ratio of the Gross enrolment ratio (%) in Sub-Saharan Africa (developing only) in 1999 to that in 2001?
Provide a short and direct response. 0.89. What is the ratio of the Gross enrolment ratio (%) of Djibouti in 1999 to that in 2001?
Ensure brevity in your answer.  0.77. What is the ratio of the Gross enrolment ratio (%) in Tunisia in 1999 to that in 2001?
Provide a short and direct response. 0.82. What is the ratio of the Gross enrolment ratio (%) of Europe(developing only) in 1999 to that in 2002?
Your response must be concise. 0.94. What is the ratio of the Gross enrolment ratio (%) of Sub-Saharan Africa (developing only) in 1999 to that in 2002?
Offer a very short reply. 0.81. What is the ratio of the Gross enrolment ratio (%) of Djibouti in 1999 to that in 2002?
Your answer should be very brief. 0.51. What is the ratio of the Gross enrolment ratio (%) in Tunisia in 1999 to that in 2002?
Your response must be concise. 0.68. What is the ratio of the Gross enrolment ratio (%) in Europe(developing only) in 2000 to that in 2001?
Offer a very short reply. 0.98. What is the ratio of the Gross enrolment ratio (%) in Sub-Saharan Africa (developing only) in 2000 to that in 2001?
Offer a very short reply. 0.96. What is the ratio of the Gross enrolment ratio (%) of Tunisia in 2000 to that in 2001?
Offer a very short reply. 0.92. What is the ratio of the Gross enrolment ratio (%) of Europe(developing only) in 2000 to that in 2002?
Offer a very short reply. 0.95. What is the ratio of the Gross enrolment ratio (%) of Sub-Saharan Africa (developing only) in 2000 to that in 2002?
Your response must be concise. 0.87. What is the ratio of the Gross enrolment ratio (%) of Djibouti in 2000 to that in 2002?
Keep it short and to the point. 0.65. What is the ratio of the Gross enrolment ratio (%) in Tunisia in 2000 to that in 2002?
Offer a terse response. 0.77. What is the ratio of the Gross enrolment ratio (%) of Europe(developing only) in 2001 to that in 2002?
Your response must be concise. 0.97. What is the ratio of the Gross enrolment ratio (%) in Sub-Saharan Africa (developing only) in 2001 to that in 2002?
Your answer should be compact. 0.91. What is the ratio of the Gross enrolment ratio (%) of Djibouti in 2001 to that in 2002?
Make the answer very short. 0.66. What is the ratio of the Gross enrolment ratio (%) in Tunisia in 2001 to that in 2002?
Provide a short and direct response. 0.83. What is the difference between the highest and the second highest Gross enrolment ratio (%) of Europe(developing only)?
Your response must be concise. 11.22. What is the difference between the highest and the second highest Gross enrolment ratio (%) in Sub-Saharan Africa (developing only)?
Give a very brief answer. 1.21. What is the difference between the highest and the second highest Gross enrolment ratio (%) of Djibouti?
Your response must be concise. 0.21. What is the difference between the highest and the second highest Gross enrolment ratio (%) of Tunisia?
Provide a short and direct response. 3.37. What is the difference between the highest and the lowest Gross enrolment ratio (%) of Europe(developing only)?
Give a very brief answer. 17.41. What is the difference between the highest and the lowest Gross enrolment ratio (%) of Sub-Saharan Africa (developing only)?
Provide a succinct answer. 3.03. What is the difference between the highest and the lowest Gross enrolment ratio (%) of Djibouti?
Provide a succinct answer. 0.39. What is the difference between the highest and the lowest Gross enrolment ratio (%) of Tunisia?
Offer a very short reply. 10.8. 